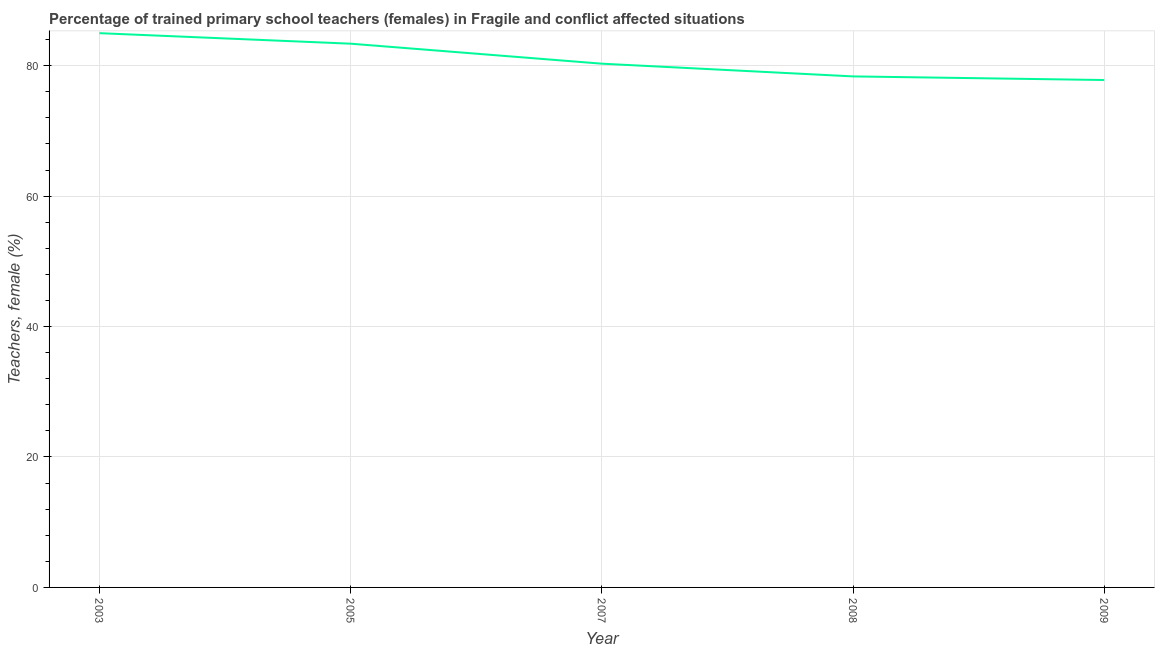What is the percentage of trained female teachers in 2007?
Make the answer very short. 80.31. Across all years, what is the maximum percentage of trained female teachers?
Keep it short and to the point. 84.99. Across all years, what is the minimum percentage of trained female teachers?
Offer a terse response. 77.81. In which year was the percentage of trained female teachers minimum?
Offer a very short reply. 2009. What is the sum of the percentage of trained female teachers?
Offer a very short reply. 404.85. What is the difference between the percentage of trained female teachers in 2005 and 2009?
Provide a short and direct response. 5.57. What is the average percentage of trained female teachers per year?
Offer a terse response. 80.97. What is the median percentage of trained female teachers?
Give a very brief answer. 80.31. Do a majority of the years between 2009 and 2005 (inclusive) have percentage of trained female teachers greater than 68 %?
Give a very brief answer. Yes. What is the ratio of the percentage of trained female teachers in 2008 to that in 2009?
Provide a succinct answer. 1.01. Is the difference between the percentage of trained female teachers in 2007 and 2009 greater than the difference between any two years?
Your response must be concise. No. What is the difference between the highest and the second highest percentage of trained female teachers?
Your response must be concise. 1.61. What is the difference between the highest and the lowest percentage of trained female teachers?
Make the answer very short. 7.18. In how many years, is the percentage of trained female teachers greater than the average percentage of trained female teachers taken over all years?
Make the answer very short. 2. How many years are there in the graph?
Keep it short and to the point. 5. Are the values on the major ticks of Y-axis written in scientific E-notation?
Give a very brief answer. No. Does the graph contain any zero values?
Keep it short and to the point. No. Does the graph contain grids?
Provide a short and direct response. Yes. What is the title of the graph?
Offer a terse response. Percentage of trained primary school teachers (females) in Fragile and conflict affected situations. What is the label or title of the X-axis?
Ensure brevity in your answer.  Year. What is the label or title of the Y-axis?
Provide a succinct answer. Teachers, female (%). What is the Teachers, female (%) in 2003?
Offer a terse response. 84.99. What is the Teachers, female (%) of 2005?
Your answer should be very brief. 83.38. What is the Teachers, female (%) of 2007?
Offer a terse response. 80.31. What is the Teachers, female (%) in 2008?
Provide a succinct answer. 78.36. What is the Teachers, female (%) in 2009?
Offer a terse response. 77.81. What is the difference between the Teachers, female (%) in 2003 and 2005?
Ensure brevity in your answer.  1.61. What is the difference between the Teachers, female (%) in 2003 and 2007?
Your answer should be very brief. 4.68. What is the difference between the Teachers, female (%) in 2003 and 2008?
Make the answer very short. 6.63. What is the difference between the Teachers, female (%) in 2003 and 2009?
Provide a short and direct response. 7.18. What is the difference between the Teachers, female (%) in 2005 and 2007?
Provide a succinct answer. 3.07. What is the difference between the Teachers, female (%) in 2005 and 2008?
Keep it short and to the point. 5.02. What is the difference between the Teachers, female (%) in 2005 and 2009?
Your response must be concise. 5.57. What is the difference between the Teachers, female (%) in 2007 and 2008?
Give a very brief answer. 1.95. What is the difference between the Teachers, female (%) in 2007 and 2009?
Offer a very short reply. 2.5. What is the difference between the Teachers, female (%) in 2008 and 2009?
Your answer should be compact. 0.56. What is the ratio of the Teachers, female (%) in 2003 to that in 2005?
Offer a terse response. 1.02. What is the ratio of the Teachers, female (%) in 2003 to that in 2007?
Provide a short and direct response. 1.06. What is the ratio of the Teachers, female (%) in 2003 to that in 2008?
Make the answer very short. 1.08. What is the ratio of the Teachers, female (%) in 2003 to that in 2009?
Provide a succinct answer. 1.09. What is the ratio of the Teachers, female (%) in 2005 to that in 2007?
Keep it short and to the point. 1.04. What is the ratio of the Teachers, female (%) in 2005 to that in 2008?
Your answer should be compact. 1.06. What is the ratio of the Teachers, female (%) in 2005 to that in 2009?
Offer a terse response. 1.07. What is the ratio of the Teachers, female (%) in 2007 to that in 2009?
Keep it short and to the point. 1.03. 